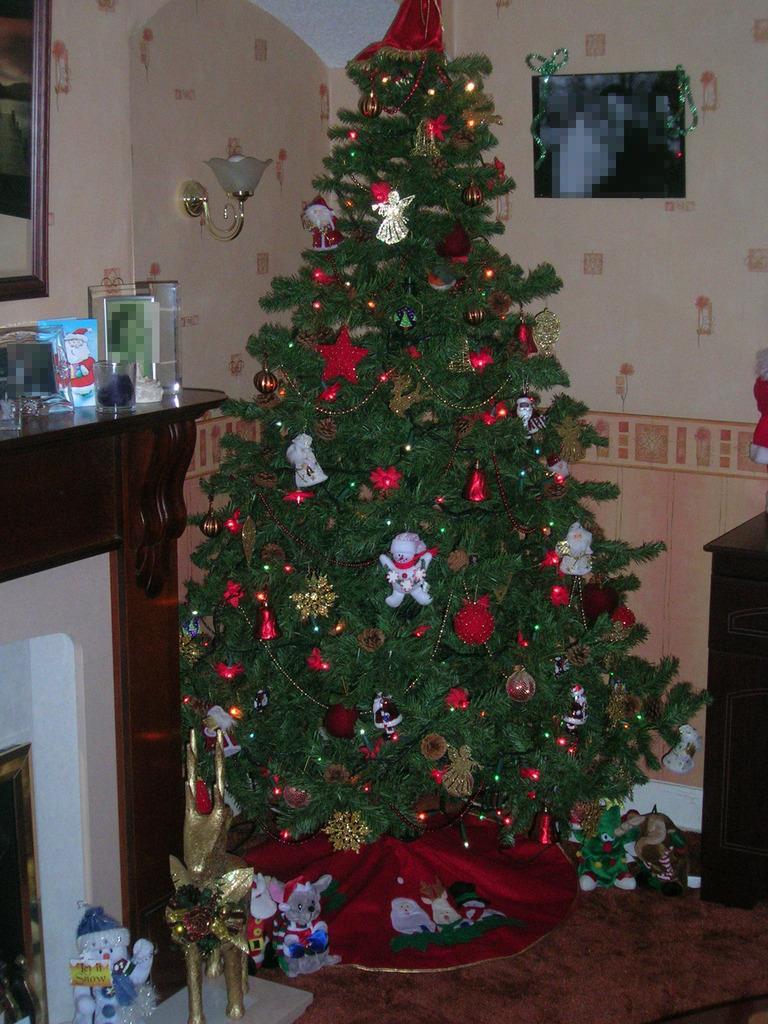Describe this image in one or two sentences. In this image we can see the decorated Christmas tree, some toys on the floor, some objects on the table, one frame with the decoration attached to the wall, one mirror attached to the wall on the top left side of the image, one light attached to the wall, one object on the bottom left side of the image and one red object near the table on the right side of the image. 